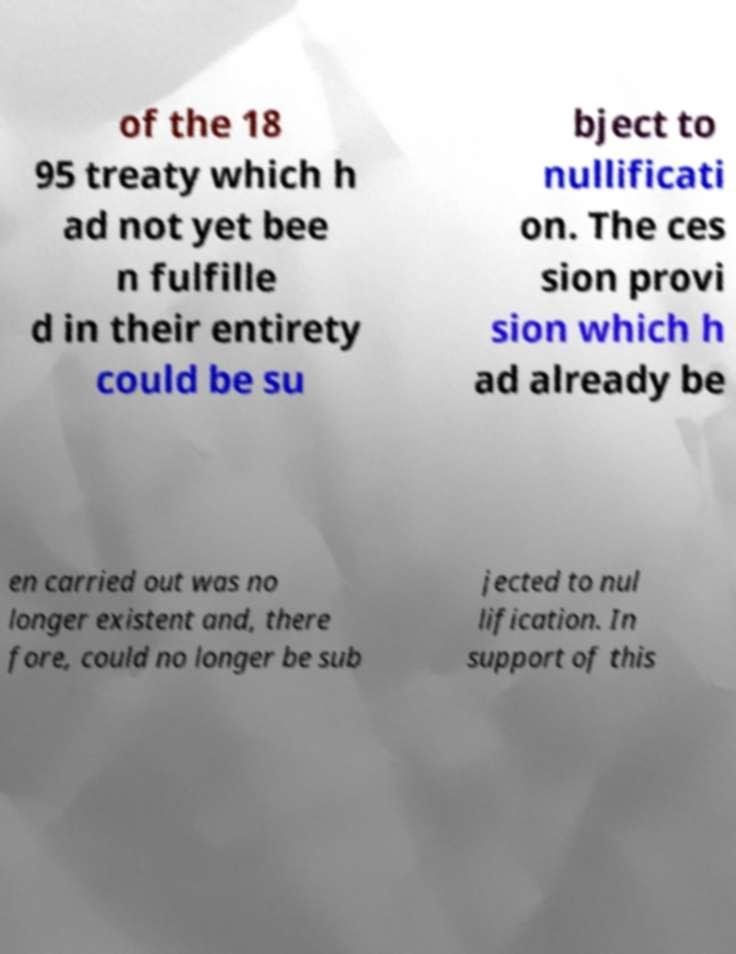Please read and relay the text visible in this image. What does it say? of the 18 95 treaty which h ad not yet bee n fulfille d in their entirety could be su bject to nullificati on. The ces sion provi sion which h ad already be en carried out was no longer existent and, there fore, could no longer be sub jected to nul lification. In support of this 